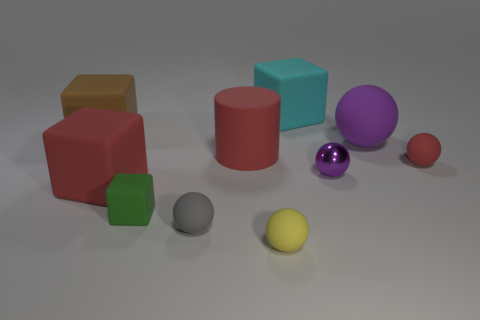Subtract all red spheres. How many spheres are left? 4 Subtract all tiny purple spheres. How many spheres are left? 4 Subtract all gray cubes. Subtract all gray spheres. How many cubes are left? 4 Subtract all cylinders. How many objects are left? 9 Add 2 small shiny objects. How many small shiny objects exist? 3 Subtract 1 green cubes. How many objects are left? 9 Subtract all tiny shiny cubes. Subtract all metal balls. How many objects are left? 9 Add 6 green rubber cubes. How many green rubber cubes are left? 7 